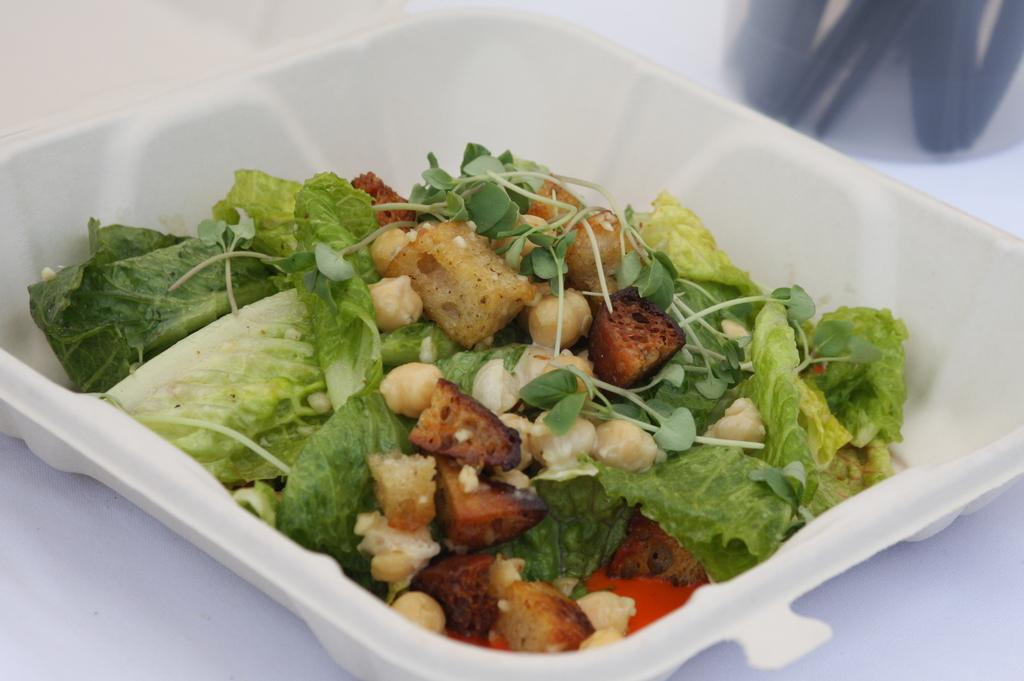What is on the plate that is visible in the image? There is a white plate in the image, and it contains salad. What specific ingredients are included in the salad? The salad includes corn and soya pieces. What type of beam can be seen supporting the plate in the image? There is no beam present in the image; the plate is resting on a surface. 